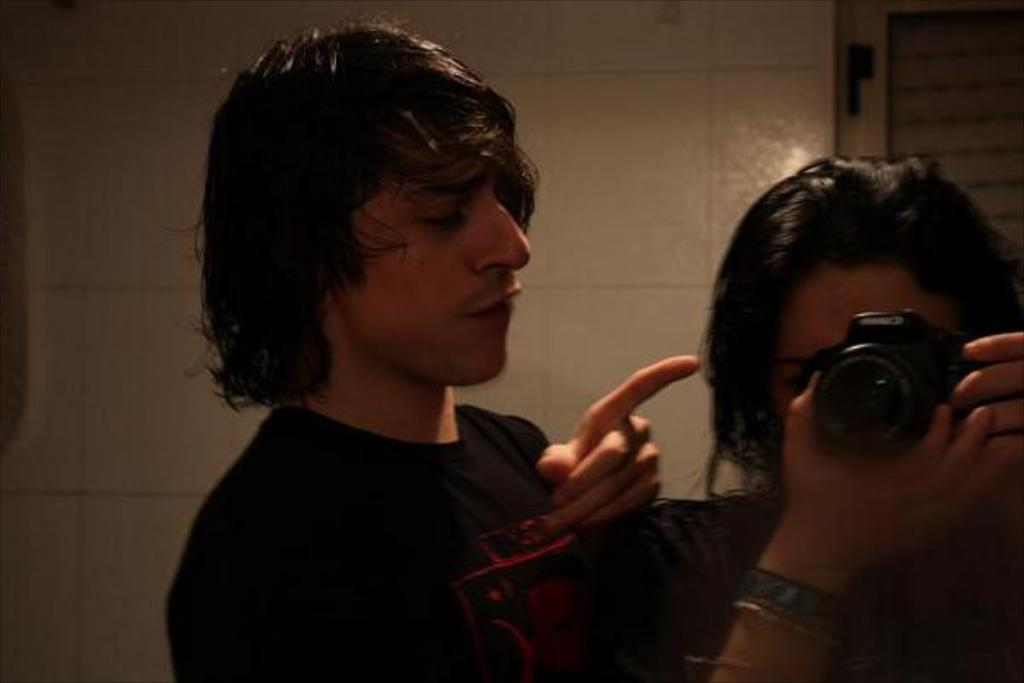How many people are present in the image? There are two people in the image, a man and a woman. What is the woman holding in her hand? The woman is carrying a camera in her hand. What type of grape is the man eating in the image? There is no grape present in the image, and the man is not eating anything. 